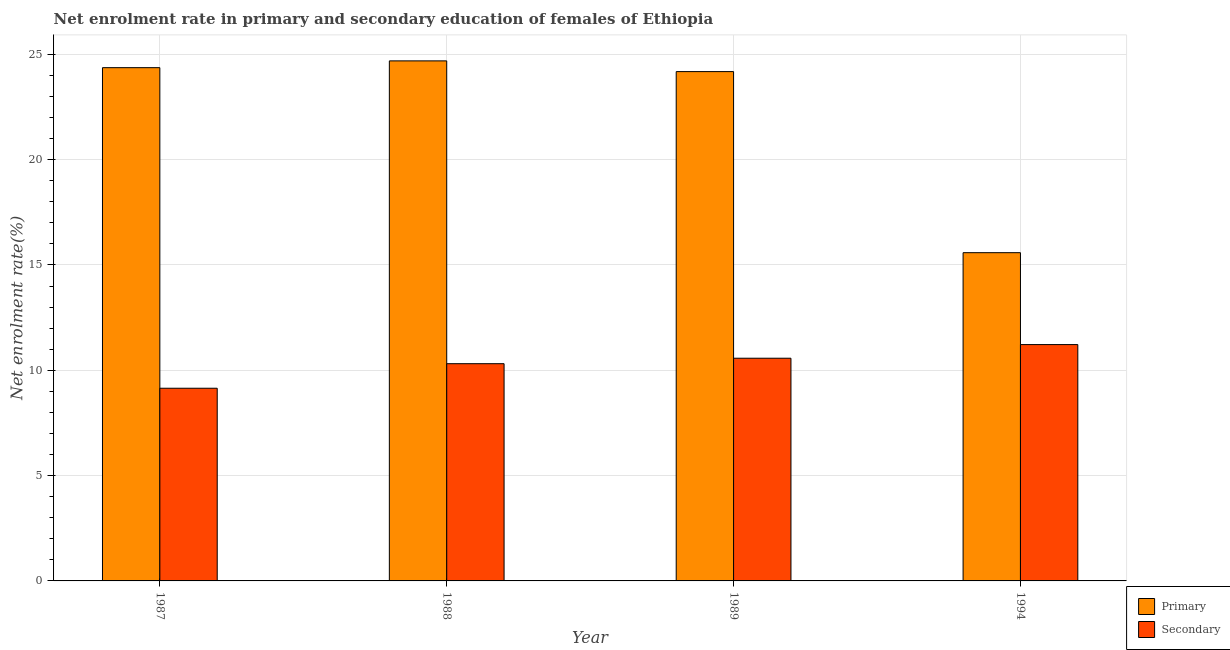How many different coloured bars are there?
Offer a very short reply. 2. Are the number of bars per tick equal to the number of legend labels?
Keep it short and to the point. Yes. Are the number of bars on each tick of the X-axis equal?
Your answer should be very brief. Yes. How many bars are there on the 4th tick from the right?
Provide a short and direct response. 2. What is the label of the 2nd group of bars from the left?
Your response must be concise. 1988. What is the enrollment rate in primary education in 1989?
Your answer should be compact. 24.18. Across all years, what is the maximum enrollment rate in secondary education?
Provide a short and direct response. 11.22. Across all years, what is the minimum enrollment rate in secondary education?
Keep it short and to the point. 9.15. In which year was the enrollment rate in secondary education maximum?
Offer a terse response. 1994. In which year was the enrollment rate in secondary education minimum?
Your answer should be compact. 1987. What is the total enrollment rate in secondary education in the graph?
Your response must be concise. 41.25. What is the difference between the enrollment rate in secondary education in 1987 and that in 1994?
Your answer should be compact. -2.07. What is the difference between the enrollment rate in primary education in 1994 and the enrollment rate in secondary education in 1987?
Your response must be concise. -8.78. What is the average enrollment rate in primary education per year?
Offer a terse response. 22.2. In the year 1988, what is the difference between the enrollment rate in primary education and enrollment rate in secondary education?
Make the answer very short. 0. In how many years, is the enrollment rate in primary education greater than 15 %?
Offer a very short reply. 4. What is the ratio of the enrollment rate in primary education in 1987 to that in 1989?
Make the answer very short. 1.01. Is the enrollment rate in primary education in 1989 less than that in 1994?
Make the answer very short. No. Is the difference between the enrollment rate in secondary education in 1988 and 1994 greater than the difference between the enrollment rate in primary education in 1988 and 1994?
Offer a terse response. No. What is the difference between the highest and the second highest enrollment rate in secondary education?
Your answer should be very brief. 0.65. What is the difference between the highest and the lowest enrollment rate in primary education?
Your response must be concise. 9.11. In how many years, is the enrollment rate in primary education greater than the average enrollment rate in primary education taken over all years?
Your answer should be very brief. 3. What does the 2nd bar from the left in 1988 represents?
Provide a succinct answer. Secondary. What does the 2nd bar from the right in 1988 represents?
Your response must be concise. Primary. Are all the bars in the graph horizontal?
Provide a short and direct response. No. Are the values on the major ticks of Y-axis written in scientific E-notation?
Your response must be concise. No. Where does the legend appear in the graph?
Your answer should be very brief. Bottom right. How many legend labels are there?
Give a very brief answer. 2. How are the legend labels stacked?
Your response must be concise. Vertical. What is the title of the graph?
Ensure brevity in your answer.  Net enrolment rate in primary and secondary education of females of Ethiopia. What is the label or title of the X-axis?
Your answer should be compact. Year. What is the label or title of the Y-axis?
Your answer should be compact. Net enrolment rate(%). What is the Net enrolment rate(%) in Primary in 1987?
Ensure brevity in your answer.  24.37. What is the Net enrolment rate(%) in Secondary in 1987?
Provide a succinct answer. 9.15. What is the Net enrolment rate(%) of Primary in 1988?
Keep it short and to the point. 24.69. What is the Net enrolment rate(%) in Secondary in 1988?
Provide a succinct answer. 10.31. What is the Net enrolment rate(%) of Primary in 1989?
Provide a succinct answer. 24.18. What is the Net enrolment rate(%) of Secondary in 1989?
Give a very brief answer. 10.57. What is the Net enrolment rate(%) in Primary in 1994?
Offer a very short reply. 15.58. What is the Net enrolment rate(%) of Secondary in 1994?
Your answer should be compact. 11.22. Across all years, what is the maximum Net enrolment rate(%) in Primary?
Keep it short and to the point. 24.69. Across all years, what is the maximum Net enrolment rate(%) in Secondary?
Give a very brief answer. 11.22. Across all years, what is the minimum Net enrolment rate(%) in Primary?
Your answer should be compact. 15.58. Across all years, what is the minimum Net enrolment rate(%) in Secondary?
Offer a terse response. 9.15. What is the total Net enrolment rate(%) in Primary in the graph?
Ensure brevity in your answer.  88.82. What is the total Net enrolment rate(%) of Secondary in the graph?
Offer a very short reply. 41.25. What is the difference between the Net enrolment rate(%) in Primary in 1987 and that in 1988?
Your answer should be very brief. -0.32. What is the difference between the Net enrolment rate(%) of Secondary in 1987 and that in 1988?
Offer a terse response. -1.17. What is the difference between the Net enrolment rate(%) of Primary in 1987 and that in 1989?
Give a very brief answer. 0.19. What is the difference between the Net enrolment rate(%) of Secondary in 1987 and that in 1989?
Offer a terse response. -1.43. What is the difference between the Net enrolment rate(%) in Primary in 1987 and that in 1994?
Provide a short and direct response. 8.78. What is the difference between the Net enrolment rate(%) of Secondary in 1987 and that in 1994?
Give a very brief answer. -2.07. What is the difference between the Net enrolment rate(%) in Primary in 1988 and that in 1989?
Your response must be concise. 0.51. What is the difference between the Net enrolment rate(%) of Secondary in 1988 and that in 1989?
Provide a succinct answer. -0.26. What is the difference between the Net enrolment rate(%) in Primary in 1988 and that in 1994?
Keep it short and to the point. 9.11. What is the difference between the Net enrolment rate(%) in Secondary in 1988 and that in 1994?
Provide a succinct answer. -0.91. What is the difference between the Net enrolment rate(%) of Primary in 1989 and that in 1994?
Ensure brevity in your answer.  8.6. What is the difference between the Net enrolment rate(%) of Secondary in 1989 and that in 1994?
Your response must be concise. -0.65. What is the difference between the Net enrolment rate(%) of Primary in 1987 and the Net enrolment rate(%) of Secondary in 1988?
Provide a succinct answer. 14.05. What is the difference between the Net enrolment rate(%) of Primary in 1987 and the Net enrolment rate(%) of Secondary in 1989?
Ensure brevity in your answer.  13.79. What is the difference between the Net enrolment rate(%) of Primary in 1987 and the Net enrolment rate(%) of Secondary in 1994?
Keep it short and to the point. 13.15. What is the difference between the Net enrolment rate(%) of Primary in 1988 and the Net enrolment rate(%) of Secondary in 1989?
Provide a succinct answer. 14.12. What is the difference between the Net enrolment rate(%) of Primary in 1988 and the Net enrolment rate(%) of Secondary in 1994?
Ensure brevity in your answer.  13.47. What is the difference between the Net enrolment rate(%) of Primary in 1989 and the Net enrolment rate(%) of Secondary in 1994?
Make the answer very short. 12.96. What is the average Net enrolment rate(%) of Primary per year?
Offer a very short reply. 22.2. What is the average Net enrolment rate(%) of Secondary per year?
Make the answer very short. 10.31. In the year 1987, what is the difference between the Net enrolment rate(%) of Primary and Net enrolment rate(%) of Secondary?
Ensure brevity in your answer.  15.22. In the year 1988, what is the difference between the Net enrolment rate(%) of Primary and Net enrolment rate(%) of Secondary?
Provide a short and direct response. 14.38. In the year 1989, what is the difference between the Net enrolment rate(%) of Primary and Net enrolment rate(%) of Secondary?
Provide a short and direct response. 13.61. In the year 1994, what is the difference between the Net enrolment rate(%) in Primary and Net enrolment rate(%) in Secondary?
Offer a very short reply. 4.36. What is the ratio of the Net enrolment rate(%) in Secondary in 1987 to that in 1988?
Your answer should be compact. 0.89. What is the ratio of the Net enrolment rate(%) of Primary in 1987 to that in 1989?
Your answer should be compact. 1.01. What is the ratio of the Net enrolment rate(%) in Secondary in 1987 to that in 1989?
Your answer should be very brief. 0.87. What is the ratio of the Net enrolment rate(%) in Primary in 1987 to that in 1994?
Provide a short and direct response. 1.56. What is the ratio of the Net enrolment rate(%) of Secondary in 1987 to that in 1994?
Offer a terse response. 0.82. What is the ratio of the Net enrolment rate(%) in Primary in 1988 to that in 1989?
Make the answer very short. 1.02. What is the ratio of the Net enrolment rate(%) in Secondary in 1988 to that in 1989?
Make the answer very short. 0.98. What is the ratio of the Net enrolment rate(%) of Primary in 1988 to that in 1994?
Provide a succinct answer. 1.58. What is the ratio of the Net enrolment rate(%) of Secondary in 1988 to that in 1994?
Provide a succinct answer. 0.92. What is the ratio of the Net enrolment rate(%) of Primary in 1989 to that in 1994?
Provide a short and direct response. 1.55. What is the ratio of the Net enrolment rate(%) in Secondary in 1989 to that in 1994?
Provide a short and direct response. 0.94. What is the difference between the highest and the second highest Net enrolment rate(%) in Primary?
Provide a short and direct response. 0.32. What is the difference between the highest and the second highest Net enrolment rate(%) in Secondary?
Offer a very short reply. 0.65. What is the difference between the highest and the lowest Net enrolment rate(%) in Primary?
Make the answer very short. 9.11. What is the difference between the highest and the lowest Net enrolment rate(%) in Secondary?
Keep it short and to the point. 2.07. 